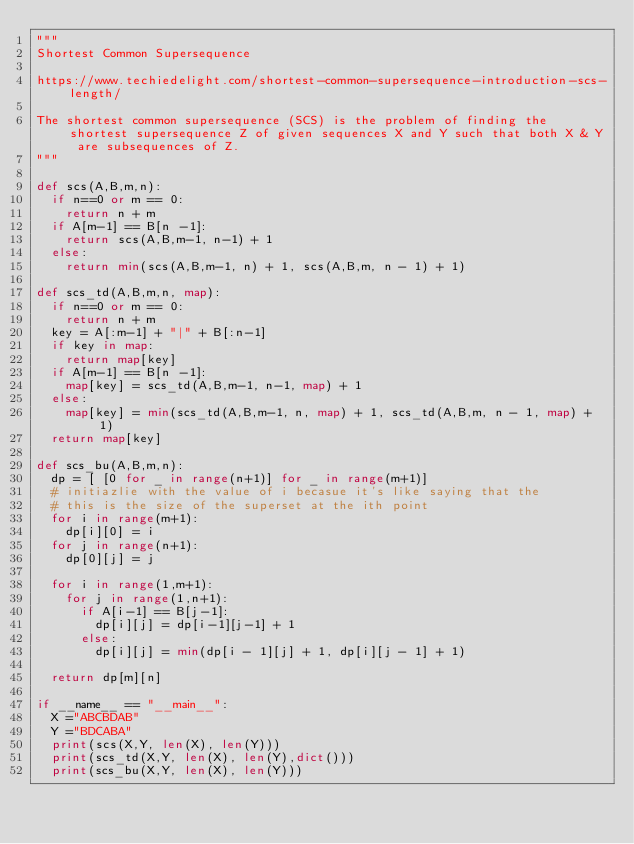<code> <loc_0><loc_0><loc_500><loc_500><_Python_>"""
Shortest Common Supersequence

https://www.techiedelight.com/shortest-common-supersequence-introduction-scs-length/

The shortest common supersequence (SCS) is the problem of finding the shortest supersequence Z of given sequences X and Y such that both X & Y are subsequences of Z.
"""

def scs(A,B,m,n):
  if n==0 or m == 0:
    return n + m
  if A[m-1] == B[n -1]:
    return scs(A,B,m-1, n-1) + 1
  else:
    return min(scs(A,B,m-1, n) + 1, scs(A,B,m, n - 1) + 1)

def scs_td(A,B,m,n, map):
  if n==0 or m == 0:
    return n + m
  key = A[:m-1] + "|" + B[:n-1]
  if key in map:
    return map[key]  
  if A[m-1] == B[n -1]:
    map[key] = scs_td(A,B,m-1, n-1, map) + 1
  else:
    map[key] = min(scs_td(A,B,m-1, n, map) + 1, scs_td(A,B,m, n - 1, map) + 1)
  return map[key]

def scs_bu(A,B,m,n):
  dp = [ [0 for _ in range(n+1)] for _ in range(m+1)]
  # initiazlie with the value of i becasue it's like saying that the
  # this is the size of the superset at the ith point
  for i in range(m+1):
    dp[i][0] = i 
  for j in range(n+1):
    dp[0][j] = j

  for i in range(1,m+1):
    for j in range(1,n+1):
      if A[i-1] == B[j-1]:
        dp[i][j] = dp[i-1][j-1] + 1
      else:
        dp[i][j] = min(dp[i - 1][j] + 1, dp[i][j - 1] + 1)

  return dp[m][n]

if __name__ == "__main__":
  X ="ABCBDAB" 
  Y ="BDCABA"
  print(scs(X,Y, len(X), len(Y)))
  print(scs_td(X,Y, len(X), len(Y),dict()))
  print(scs_bu(X,Y, len(X), len(Y)))
</code> 